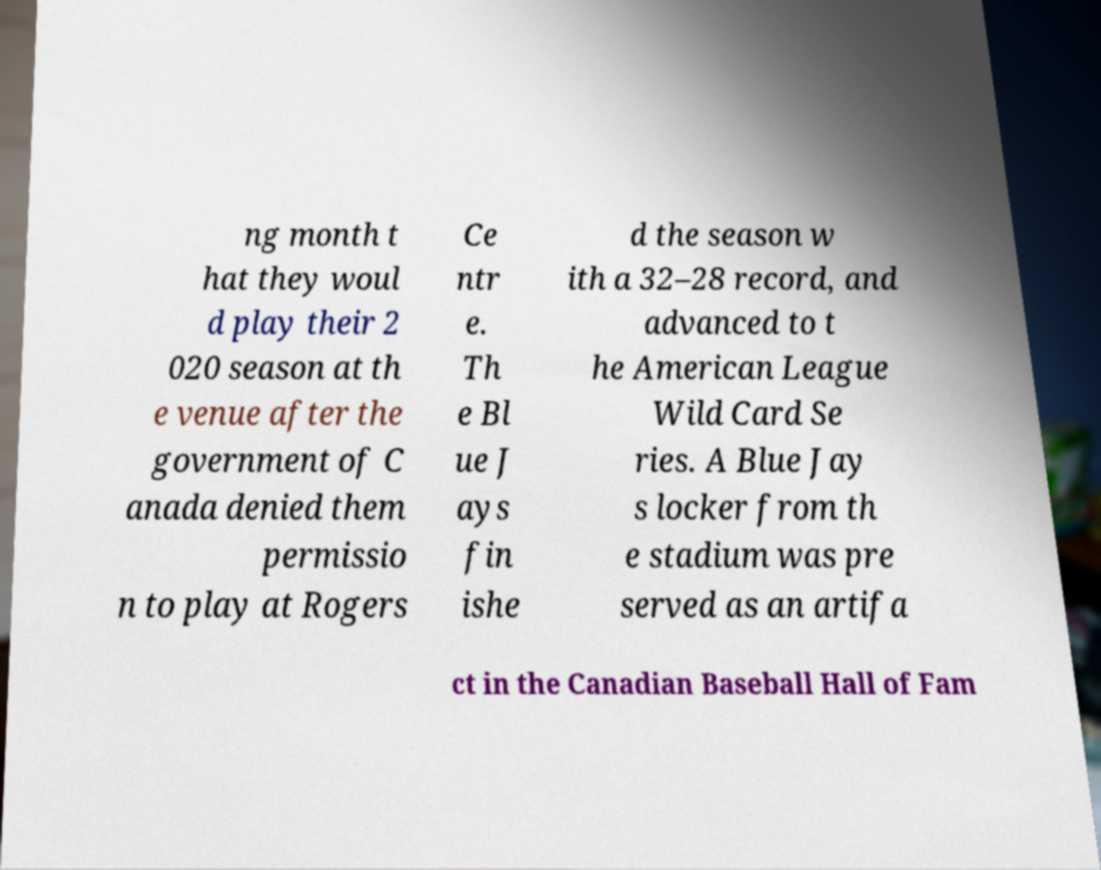Could you extract and type out the text from this image? ng month t hat they woul d play their 2 020 season at th e venue after the government of C anada denied them permissio n to play at Rogers Ce ntr e. Th e Bl ue J ays fin ishe d the season w ith a 32–28 record, and advanced to t he American League Wild Card Se ries. A Blue Jay s locker from th e stadium was pre served as an artifa ct in the Canadian Baseball Hall of Fam 